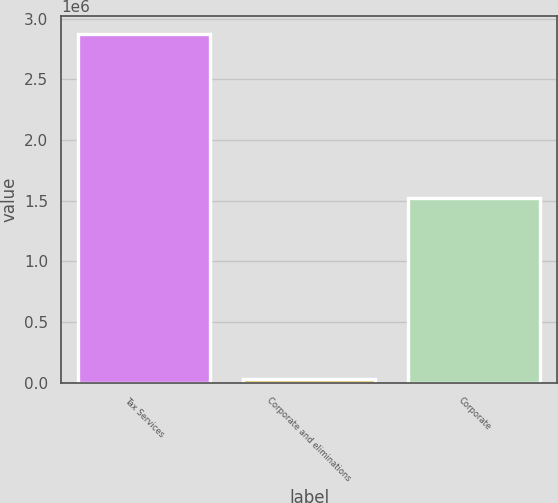Convert chart. <chart><loc_0><loc_0><loc_500><loc_500><bar_chart><fcel>Tax Services<fcel>Corporate and eliminations<fcel>Corporate<nl><fcel>2.87797e+06<fcel>27976<fcel>1.52525e+06<nl></chart> 